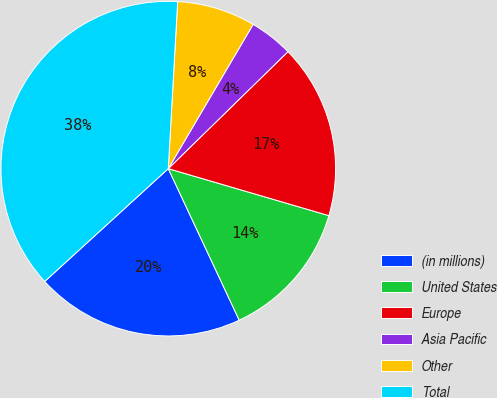Convert chart. <chart><loc_0><loc_0><loc_500><loc_500><pie_chart><fcel>(in millions)<fcel>United States<fcel>Europe<fcel>Asia Pacific<fcel>Other<fcel>Total<nl><fcel>20.19%<fcel>13.5%<fcel>16.85%<fcel>4.22%<fcel>7.57%<fcel>37.67%<nl></chart> 